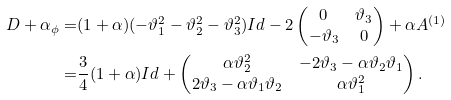<formula> <loc_0><loc_0><loc_500><loc_500>D + \alpha \L _ { \phi } = & ( 1 + \alpha ) ( - \vartheta _ { 1 } ^ { 2 } - \vartheta _ { 2 } ^ { 2 } - \vartheta _ { 3 } ^ { 2 } ) I d - 2 \begin{pmatrix} 0 & \vartheta _ { 3 } \\ - \vartheta _ { 3 } & 0 \end{pmatrix} + \alpha A ^ { ( 1 ) } \\ = & \frac { 3 } { 4 } ( 1 + \alpha ) I d + \begin{pmatrix} \alpha \vartheta _ { 2 } ^ { 2 } & - 2 \vartheta _ { 3 } - \alpha \vartheta _ { 2 } \vartheta _ { 1 } \\ 2 \vartheta _ { 3 } - \alpha \vartheta _ { 1 } \vartheta _ { 2 } & \alpha \vartheta _ { 1 } ^ { 2 } \end{pmatrix} .</formula> 